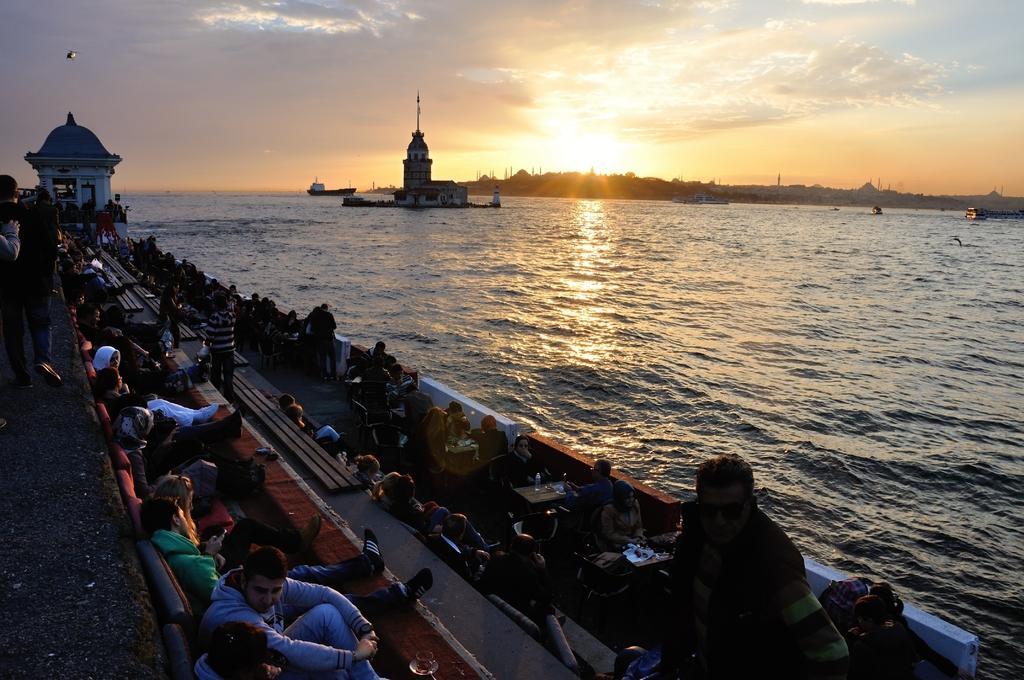Could you give a brief overview of what you see in this image? In this picture I can see number of people in front and I see most of them are sitting on chairs and few of them are standing and I see few tables. In the background I can see the water, on which I can see a building and I see few boats. On the top of this picture I can see the cloudy sky and I can also see the sun. 